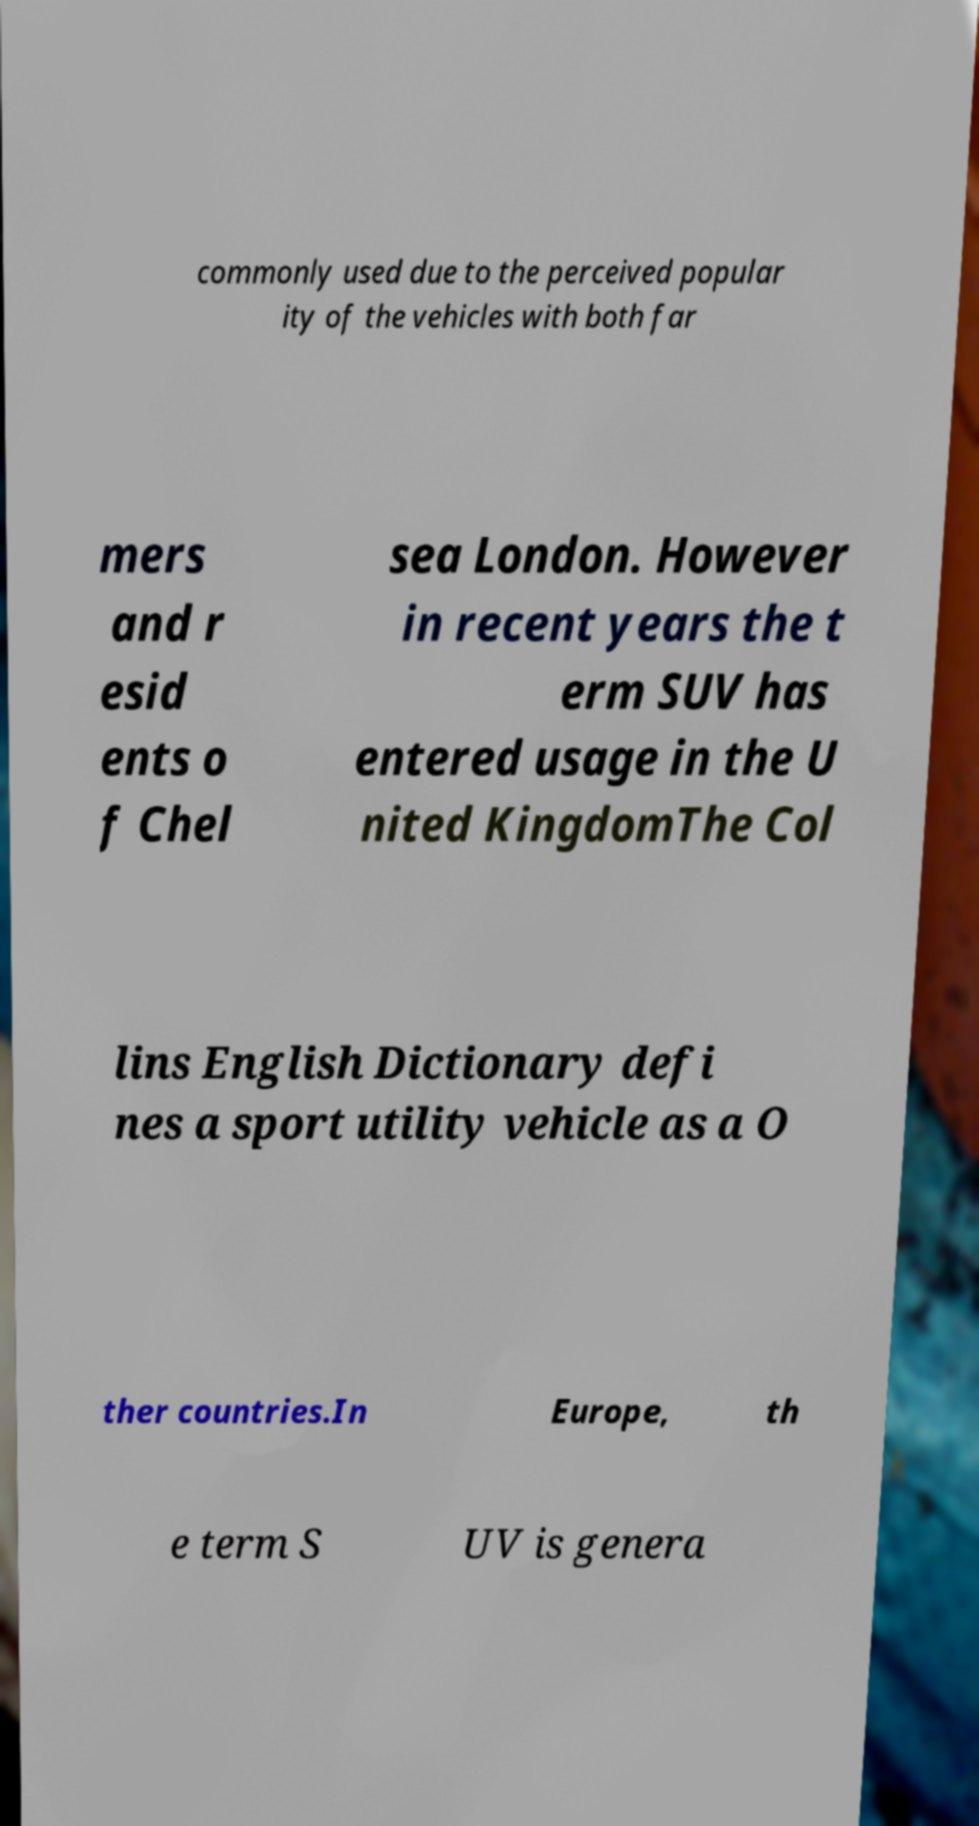Could you assist in decoding the text presented in this image and type it out clearly? commonly used due to the perceived popular ity of the vehicles with both far mers and r esid ents o f Chel sea London. However in recent years the t erm SUV has entered usage in the U nited KingdomThe Col lins English Dictionary defi nes a sport utility vehicle as a O ther countries.In Europe, th e term S UV is genera 